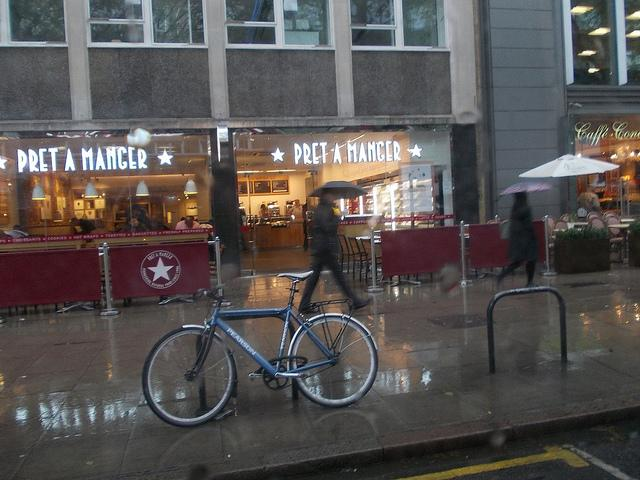What time of day is it here? evening 